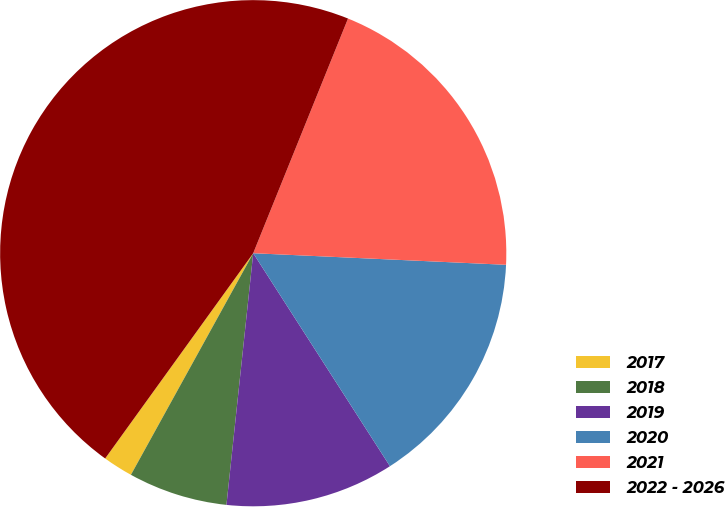<chart> <loc_0><loc_0><loc_500><loc_500><pie_chart><fcel>2017<fcel>2018<fcel>2019<fcel>2020<fcel>2021<fcel>2022 - 2026<nl><fcel>1.92%<fcel>6.34%<fcel>10.77%<fcel>15.19%<fcel>19.62%<fcel>46.17%<nl></chart> 